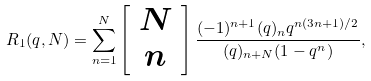Convert formula to latex. <formula><loc_0><loc_0><loc_500><loc_500>R _ { 1 } ( q , N ) = \sum _ { n = 1 } ^ { N } \left [ \begin{array} { c } N \\ n \end{array} \right ] \frac { ( - 1 ) ^ { n + 1 } ( q ) _ { n } q ^ { n ( 3 n + 1 ) / 2 } } { ( q ) _ { n + N } ( 1 - q ^ { n } ) } ,</formula> 